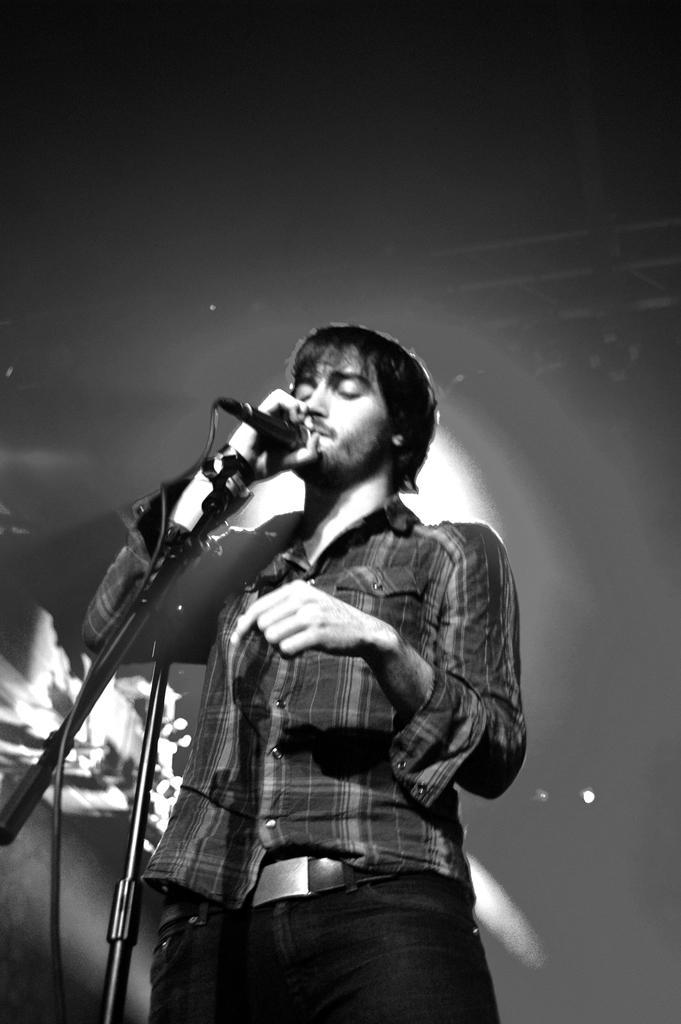Can you describe this image briefly? This image seems like a man standing and singing with a mic in his hand. 